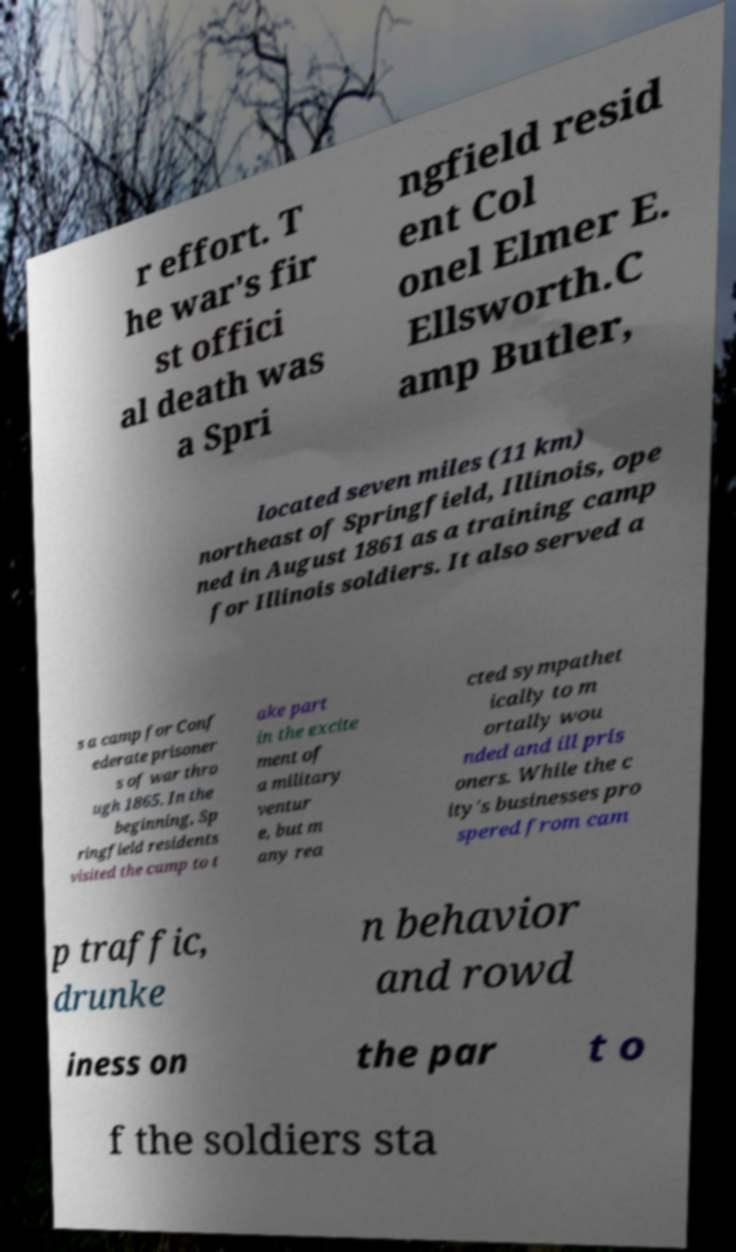Could you extract and type out the text from this image? r effort. T he war's fir st offici al death was a Spri ngfield resid ent Col onel Elmer E. Ellsworth.C amp Butler, located seven miles (11 km) northeast of Springfield, Illinois, ope ned in August 1861 as a training camp for Illinois soldiers. It also served a s a camp for Conf ederate prisoner s of war thro ugh 1865. In the beginning, Sp ringfield residents visited the camp to t ake part in the excite ment of a military ventur e, but m any rea cted sympathet ically to m ortally wou nded and ill pris oners. While the c ity's businesses pro spered from cam p traffic, drunke n behavior and rowd iness on the par t o f the soldiers sta 